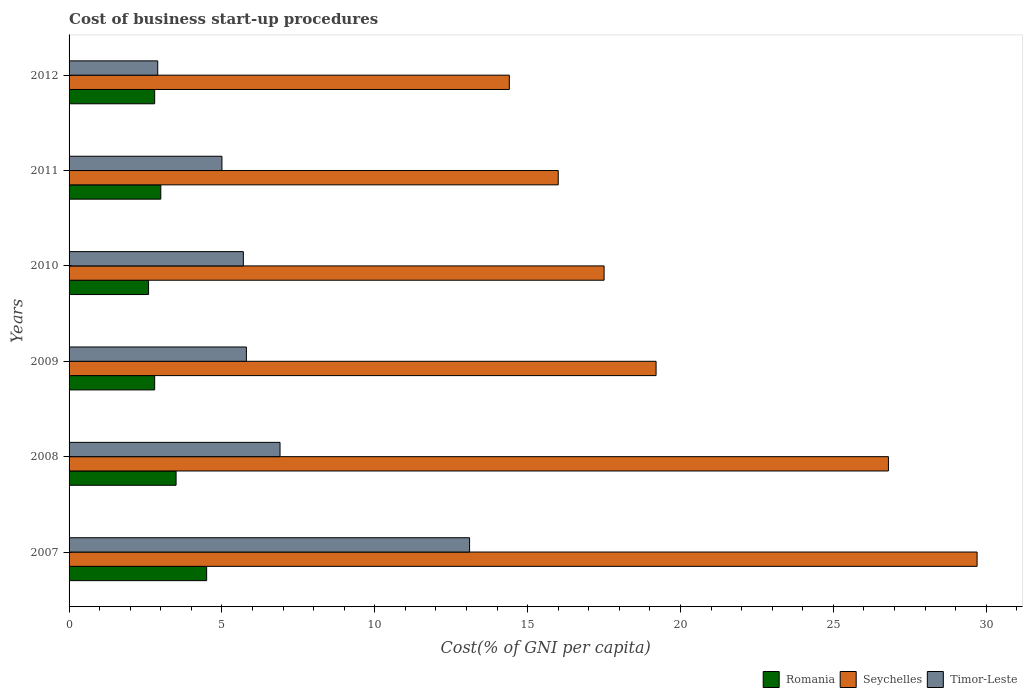How many groups of bars are there?
Provide a short and direct response. 6. Are the number of bars per tick equal to the number of legend labels?
Your answer should be very brief. Yes. Are the number of bars on each tick of the Y-axis equal?
Your response must be concise. Yes. How many bars are there on the 1st tick from the top?
Your answer should be compact. 3. How many bars are there on the 2nd tick from the bottom?
Keep it short and to the point. 3. What is the label of the 5th group of bars from the top?
Give a very brief answer. 2008. What is the cost of business start-up procedures in Seychelles in 2009?
Offer a very short reply. 19.2. Across all years, what is the maximum cost of business start-up procedures in Seychelles?
Provide a succinct answer. 29.7. Across all years, what is the minimum cost of business start-up procedures in Timor-Leste?
Make the answer very short. 2.9. In which year was the cost of business start-up procedures in Seychelles minimum?
Offer a very short reply. 2012. What is the total cost of business start-up procedures in Timor-Leste in the graph?
Keep it short and to the point. 39.4. What is the average cost of business start-up procedures in Seychelles per year?
Ensure brevity in your answer.  20.6. In the year 2011, what is the difference between the cost of business start-up procedures in Romania and cost of business start-up procedures in Timor-Leste?
Give a very brief answer. -2. What is the ratio of the cost of business start-up procedures in Seychelles in 2007 to that in 2009?
Offer a terse response. 1.55. Is the difference between the cost of business start-up procedures in Romania in 2009 and 2012 greater than the difference between the cost of business start-up procedures in Timor-Leste in 2009 and 2012?
Provide a short and direct response. No. What is the difference between the highest and the lowest cost of business start-up procedures in Seychelles?
Your response must be concise. 15.3. Is the sum of the cost of business start-up procedures in Timor-Leste in 2010 and 2011 greater than the maximum cost of business start-up procedures in Seychelles across all years?
Give a very brief answer. No. What does the 2nd bar from the top in 2010 represents?
Give a very brief answer. Seychelles. What does the 3rd bar from the bottom in 2008 represents?
Your answer should be very brief. Timor-Leste. Is it the case that in every year, the sum of the cost of business start-up procedures in Romania and cost of business start-up procedures in Seychelles is greater than the cost of business start-up procedures in Timor-Leste?
Make the answer very short. Yes. How many bars are there?
Ensure brevity in your answer.  18. What is the difference between two consecutive major ticks on the X-axis?
Your response must be concise. 5. Does the graph contain grids?
Keep it short and to the point. No. Where does the legend appear in the graph?
Provide a short and direct response. Bottom right. How are the legend labels stacked?
Your answer should be very brief. Horizontal. What is the title of the graph?
Offer a very short reply. Cost of business start-up procedures. Does "Slovenia" appear as one of the legend labels in the graph?
Offer a terse response. No. What is the label or title of the X-axis?
Your response must be concise. Cost(% of GNI per capita). What is the Cost(% of GNI per capita) of Romania in 2007?
Make the answer very short. 4.5. What is the Cost(% of GNI per capita) of Seychelles in 2007?
Your response must be concise. 29.7. What is the Cost(% of GNI per capita) of Timor-Leste in 2007?
Your answer should be very brief. 13.1. What is the Cost(% of GNI per capita) of Seychelles in 2008?
Your answer should be very brief. 26.8. What is the Cost(% of GNI per capita) of Seychelles in 2009?
Ensure brevity in your answer.  19.2. What is the Cost(% of GNI per capita) in Seychelles in 2010?
Ensure brevity in your answer.  17.5. What is the Cost(% of GNI per capita) of Timor-Leste in 2011?
Provide a short and direct response. 5. What is the Cost(% of GNI per capita) of Romania in 2012?
Your answer should be very brief. 2.8. Across all years, what is the maximum Cost(% of GNI per capita) in Seychelles?
Your answer should be very brief. 29.7. Across all years, what is the minimum Cost(% of GNI per capita) in Romania?
Offer a terse response. 2.6. What is the total Cost(% of GNI per capita) in Seychelles in the graph?
Provide a succinct answer. 123.6. What is the total Cost(% of GNI per capita) of Timor-Leste in the graph?
Make the answer very short. 39.4. What is the difference between the Cost(% of GNI per capita) of Timor-Leste in 2007 and that in 2008?
Offer a terse response. 6.2. What is the difference between the Cost(% of GNI per capita) in Timor-Leste in 2007 and that in 2009?
Your answer should be compact. 7.3. What is the difference between the Cost(% of GNI per capita) of Timor-Leste in 2007 and that in 2010?
Offer a very short reply. 7.4. What is the difference between the Cost(% of GNI per capita) of Romania in 2007 and that in 2012?
Offer a very short reply. 1.7. What is the difference between the Cost(% of GNI per capita) of Seychelles in 2007 and that in 2012?
Your response must be concise. 15.3. What is the difference between the Cost(% of GNI per capita) in Seychelles in 2008 and that in 2009?
Provide a succinct answer. 7.6. What is the difference between the Cost(% of GNI per capita) of Seychelles in 2008 and that in 2010?
Ensure brevity in your answer.  9.3. What is the difference between the Cost(% of GNI per capita) of Timor-Leste in 2008 and that in 2010?
Offer a terse response. 1.2. What is the difference between the Cost(% of GNI per capita) in Romania in 2008 and that in 2011?
Make the answer very short. 0.5. What is the difference between the Cost(% of GNI per capita) of Seychelles in 2008 and that in 2011?
Your response must be concise. 10.8. What is the difference between the Cost(% of GNI per capita) of Romania in 2008 and that in 2012?
Provide a short and direct response. 0.7. What is the difference between the Cost(% of GNI per capita) in Seychelles in 2008 and that in 2012?
Provide a short and direct response. 12.4. What is the difference between the Cost(% of GNI per capita) in Romania in 2009 and that in 2010?
Keep it short and to the point. 0.2. What is the difference between the Cost(% of GNI per capita) of Romania in 2009 and that in 2011?
Offer a very short reply. -0.2. What is the difference between the Cost(% of GNI per capita) in Romania in 2009 and that in 2012?
Ensure brevity in your answer.  0. What is the difference between the Cost(% of GNI per capita) in Timor-Leste in 2009 and that in 2012?
Provide a succinct answer. 2.9. What is the difference between the Cost(% of GNI per capita) in Seychelles in 2010 and that in 2012?
Give a very brief answer. 3.1. What is the difference between the Cost(% of GNI per capita) of Timor-Leste in 2010 and that in 2012?
Keep it short and to the point. 2.8. What is the difference between the Cost(% of GNI per capita) in Seychelles in 2011 and that in 2012?
Provide a short and direct response. 1.6. What is the difference between the Cost(% of GNI per capita) in Romania in 2007 and the Cost(% of GNI per capita) in Seychelles in 2008?
Offer a terse response. -22.3. What is the difference between the Cost(% of GNI per capita) of Seychelles in 2007 and the Cost(% of GNI per capita) of Timor-Leste in 2008?
Your answer should be compact. 22.8. What is the difference between the Cost(% of GNI per capita) in Romania in 2007 and the Cost(% of GNI per capita) in Seychelles in 2009?
Offer a very short reply. -14.7. What is the difference between the Cost(% of GNI per capita) of Seychelles in 2007 and the Cost(% of GNI per capita) of Timor-Leste in 2009?
Ensure brevity in your answer.  23.9. What is the difference between the Cost(% of GNI per capita) of Romania in 2007 and the Cost(% of GNI per capita) of Timor-Leste in 2010?
Offer a very short reply. -1.2. What is the difference between the Cost(% of GNI per capita) in Seychelles in 2007 and the Cost(% of GNI per capita) in Timor-Leste in 2010?
Your response must be concise. 24. What is the difference between the Cost(% of GNI per capita) in Romania in 2007 and the Cost(% of GNI per capita) in Seychelles in 2011?
Provide a succinct answer. -11.5. What is the difference between the Cost(% of GNI per capita) of Seychelles in 2007 and the Cost(% of GNI per capita) of Timor-Leste in 2011?
Make the answer very short. 24.7. What is the difference between the Cost(% of GNI per capita) of Romania in 2007 and the Cost(% of GNI per capita) of Seychelles in 2012?
Make the answer very short. -9.9. What is the difference between the Cost(% of GNI per capita) of Romania in 2007 and the Cost(% of GNI per capita) of Timor-Leste in 2012?
Your answer should be very brief. 1.6. What is the difference between the Cost(% of GNI per capita) in Seychelles in 2007 and the Cost(% of GNI per capita) in Timor-Leste in 2012?
Your answer should be compact. 26.8. What is the difference between the Cost(% of GNI per capita) of Romania in 2008 and the Cost(% of GNI per capita) of Seychelles in 2009?
Keep it short and to the point. -15.7. What is the difference between the Cost(% of GNI per capita) of Romania in 2008 and the Cost(% of GNI per capita) of Timor-Leste in 2010?
Your answer should be compact. -2.2. What is the difference between the Cost(% of GNI per capita) in Seychelles in 2008 and the Cost(% of GNI per capita) in Timor-Leste in 2010?
Provide a succinct answer. 21.1. What is the difference between the Cost(% of GNI per capita) of Seychelles in 2008 and the Cost(% of GNI per capita) of Timor-Leste in 2011?
Offer a terse response. 21.8. What is the difference between the Cost(% of GNI per capita) of Seychelles in 2008 and the Cost(% of GNI per capita) of Timor-Leste in 2012?
Provide a short and direct response. 23.9. What is the difference between the Cost(% of GNI per capita) of Romania in 2009 and the Cost(% of GNI per capita) of Seychelles in 2010?
Offer a terse response. -14.7. What is the difference between the Cost(% of GNI per capita) in Romania in 2009 and the Cost(% of GNI per capita) in Timor-Leste in 2010?
Offer a terse response. -2.9. What is the difference between the Cost(% of GNI per capita) in Seychelles in 2009 and the Cost(% of GNI per capita) in Timor-Leste in 2010?
Offer a very short reply. 13.5. What is the difference between the Cost(% of GNI per capita) of Romania in 2009 and the Cost(% of GNI per capita) of Seychelles in 2011?
Provide a short and direct response. -13.2. What is the difference between the Cost(% of GNI per capita) of Romania in 2009 and the Cost(% of GNI per capita) of Timor-Leste in 2011?
Keep it short and to the point. -2.2. What is the difference between the Cost(% of GNI per capita) of Seychelles in 2009 and the Cost(% of GNI per capita) of Timor-Leste in 2011?
Offer a terse response. 14.2. What is the difference between the Cost(% of GNI per capita) in Romania in 2009 and the Cost(% of GNI per capita) in Seychelles in 2012?
Offer a very short reply. -11.6. What is the difference between the Cost(% of GNI per capita) of Seychelles in 2009 and the Cost(% of GNI per capita) of Timor-Leste in 2012?
Your answer should be compact. 16.3. What is the difference between the Cost(% of GNI per capita) in Romania in 2010 and the Cost(% of GNI per capita) in Seychelles in 2011?
Your answer should be compact. -13.4. What is the difference between the Cost(% of GNI per capita) in Seychelles in 2010 and the Cost(% of GNI per capita) in Timor-Leste in 2011?
Keep it short and to the point. 12.5. What is the difference between the Cost(% of GNI per capita) in Romania in 2010 and the Cost(% of GNI per capita) in Seychelles in 2012?
Ensure brevity in your answer.  -11.8. What is the difference between the Cost(% of GNI per capita) in Seychelles in 2010 and the Cost(% of GNI per capita) in Timor-Leste in 2012?
Offer a very short reply. 14.6. What is the average Cost(% of GNI per capita) in Seychelles per year?
Provide a short and direct response. 20.6. What is the average Cost(% of GNI per capita) in Timor-Leste per year?
Provide a succinct answer. 6.57. In the year 2007, what is the difference between the Cost(% of GNI per capita) in Romania and Cost(% of GNI per capita) in Seychelles?
Give a very brief answer. -25.2. In the year 2007, what is the difference between the Cost(% of GNI per capita) in Seychelles and Cost(% of GNI per capita) in Timor-Leste?
Your response must be concise. 16.6. In the year 2008, what is the difference between the Cost(% of GNI per capita) in Romania and Cost(% of GNI per capita) in Seychelles?
Give a very brief answer. -23.3. In the year 2008, what is the difference between the Cost(% of GNI per capita) in Romania and Cost(% of GNI per capita) in Timor-Leste?
Offer a terse response. -3.4. In the year 2008, what is the difference between the Cost(% of GNI per capita) of Seychelles and Cost(% of GNI per capita) of Timor-Leste?
Your response must be concise. 19.9. In the year 2009, what is the difference between the Cost(% of GNI per capita) in Romania and Cost(% of GNI per capita) in Seychelles?
Keep it short and to the point. -16.4. In the year 2009, what is the difference between the Cost(% of GNI per capita) of Romania and Cost(% of GNI per capita) of Timor-Leste?
Provide a succinct answer. -3. In the year 2010, what is the difference between the Cost(% of GNI per capita) in Romania and Cost(% of GNI per capita) in Seychelles?
Ensure brevity in your answer.  -14.9. In the year 2010, what is the difference between the Cost(% of GNI per capita) of Romania and Cost(% of GNI per capita) of Timor-Leste?
Keep it short and to the point. -3.1. In the year 2011, what is the difference between the Cost(% of GNI per capita) in Seychelles and Cost(% of GNI per capita) in Timor-Leste?
Offer a very short reply. 11. In the year 2012, what is the difference between the Cost(% of GNI per capita) of Romania and Cost(% of GNI per capita) of Timor-Leste?
Keep it short and to the point. -0.1. In the year 2012, what is the difference between the Cost(% of GNI per capita) of Seychelles and Cost(% of GNI per capita) of Timor-Leste?
Provide a short and direct response. 11.5. What is the ratio of the Cost(% of GNI per capita) of Seychelles in 2007 to that in 2008?
Give a very brief answer. 1.11. What is the ratio of the Cost(% of GNI per capita) in Timor-Leste in 2007 to that in 2008?
Offer a terse response. 1.9. What is the ratio of the Cost(% of GNI per capita) in Romania in 2007 to that in 2009?
Keep it short and to the point. 1.61. What is the ratio of the Cost(% of GNI per capita) in Seychelles in 2007 to that in 2009?
Provide a short and direct response. 1.55. What is the ratio of the Cost(% of GNI per capita) of Timor-Leste in 2007 to that in 2009?
Your answer should be very brief. 2.26. What is the ratio of the Cost(% of GNI per capita) of Romania in 2007 to that in 2010?
Give a very brief answer. 1.73. What is the ratio of the Cost(% of GNI per capita) of Seychelles in 2007 to that in 2010?
Make the answer very short. 1.7. What is the ratio of the Cost(% of GNI per capita) in Timor-Leste in 2007 to that in 2010?
Provide a short and direct response. 2.3. What is the ratio of the Cost(% of GNI per capita) in Seychelles in 2007 to that in 2011?
Provide a short and direct response. 1.86. What is the ratio of the Cost(% of GNI per capita) of Timor-Leste in 2007 to that in 2011?
Give a very brief answer. 2.62. What is the ratio of the Cost(% of GNI per capita) of Romania in 2007 to that in 2012?
Provide a succinct answer. 1.61. What is the ratio of the Cost(% of GNI per capita) in Seychelles in 2007 to that in 2012?
Offer a terse response. 2.06. What is the ratio of the Cost(% of GNI per capita) of Timor-Leste in 2007 to that in 2012?
Make the answer very short. 4.52. What is the ratio of the Cost(% of GNI per capita) in Seychelles in 2008 to that in 2009?
Ensure brevity in your answer.  1.4. What is the ratio of the Cost(% of GNI per capita) in Timor-Leste in 2008 to that in 2009?
Offer a very short reply. 1.19. What is the ratio of the Cost(% of GNI per capita) in Romania in 2008 to that in 2010?
Give a very brief answer. 1.35. What is the ratio of the Cost(% of GNI per capita) in Seychelles in 2008 to that in 2010?
Offer a very short reply. 1.53. What is the ratio of the Cost(% of GNI per capita) in Timor-Leste in 2008 to that in 2010?
Provide a succinct answer. 1.21. What is the ratio of the Cost(% of GNI per capita) in Seychelles in 2008 to that in 2011?
Your answer should be very brief. 1.68. What is the ratio of the Cost(% of GNI per capita) in Timor-Leste in 2008 to that in 2011?
Your response must be concise. 1.38. What is the ratio of the Cost(% of GNI per capita) of Seychelles in 2008 to that in 2012?
Make the answer very short. 1.86. What is the ratio of the Cost(% of GNI per capita) in Timor-Leste in 2008 to that in 2012?
Provide a succinct answer. 2.38. What is the ratio of the Cost(% of GNI per capita) in Seychelles in 2009 to that in 2010?
Your answer should be very brief. 1.1. What is the ratio of the Cost(% of GNI per capita) in Timor-Leste in 2009 to that in 2010?
Offer a terse response. 1.02. What is the ratio of the Cost(% of GNI per capita) in Romania in 2009 to that in 2011?
Keep it short and to the point. 0.93. What is the ratio of the Cost(% of GNI per capita) of Timor-Leste in 2009 to that in 2011?
Offer a very short reply. 1.16. What is the ratio of the Cost(% of GNI per capita) of Romania in 2010 to that in 2011?
Provide a short and direct response. 0.87. What is the ratio of the Cost(% of GNI per capita) of Seychelles in 2010 to that in 2011?
Your answer should be compact. 1.09. What is the ratio of the Cost(% of GNI per capita) of Timor-Leste in 2010 to that in 2011?
Your response must be concise. 1.14. What is the ratio of the Cost(% of GNI per capita) of Romania in 2010 to that in 2012?
Your answer should be very brief. 0.93. What is the ratio of the Cost(% of GNI per capita) of Seychelles in 2010 to that in 2012?
Make the answer very short. 1.22. What is the ratio of the Cost(% of GNI per capita) in Timor-Leste in 2010 to that in 2012?
Your answer should be compact. 1.97. What is the ratio of the Cost(% of GNI per capita) in Romania in 2011 to that in 2012?
Keep it short and to the point. 1.07. What is the ratio of the Cost(% of GNI per capita) of Timor-Leste in 2011 to that in 2012?
Provide a short and direct response. 1.72. What is the difference between the highest and the second highest Cost(% of GNI per capita) in Romania?
Give a very brief answer. 1. What is the difference between the highest and the second highest Cost(% of GNI per capita) of Timor-Leste?
Give a very brief answer. 6.2. 